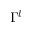<formula> <loc_0><loc_0><loc_500><loc_500>\Gamma ^ { l }</formula> 